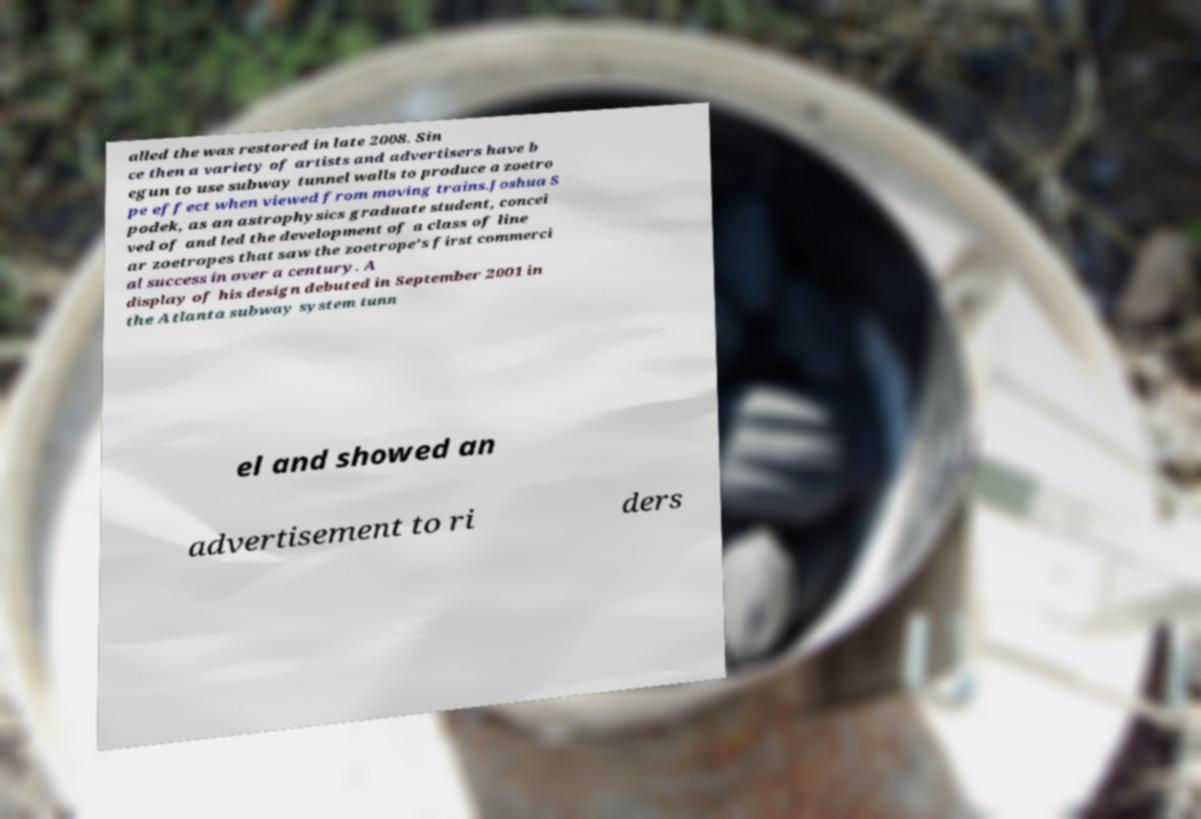Can you accurately transcribe the text from the provided image for me? alled the was restored in late 2008. Sin ce then a variety of artists and advertisers have b egun to use subway tunnel walls to produce a zoetro pe effect when viewed from moving trains.Joshua S podek, as an astrophysics graduate student, concei ved of and led the development of a class of line ar zoetropes that saw the zoetrope's first commerci al success in over a century. A display of his design debuted in September 2001 in the Atlanta subway system tunn el and showed an advertisement to ri ders 